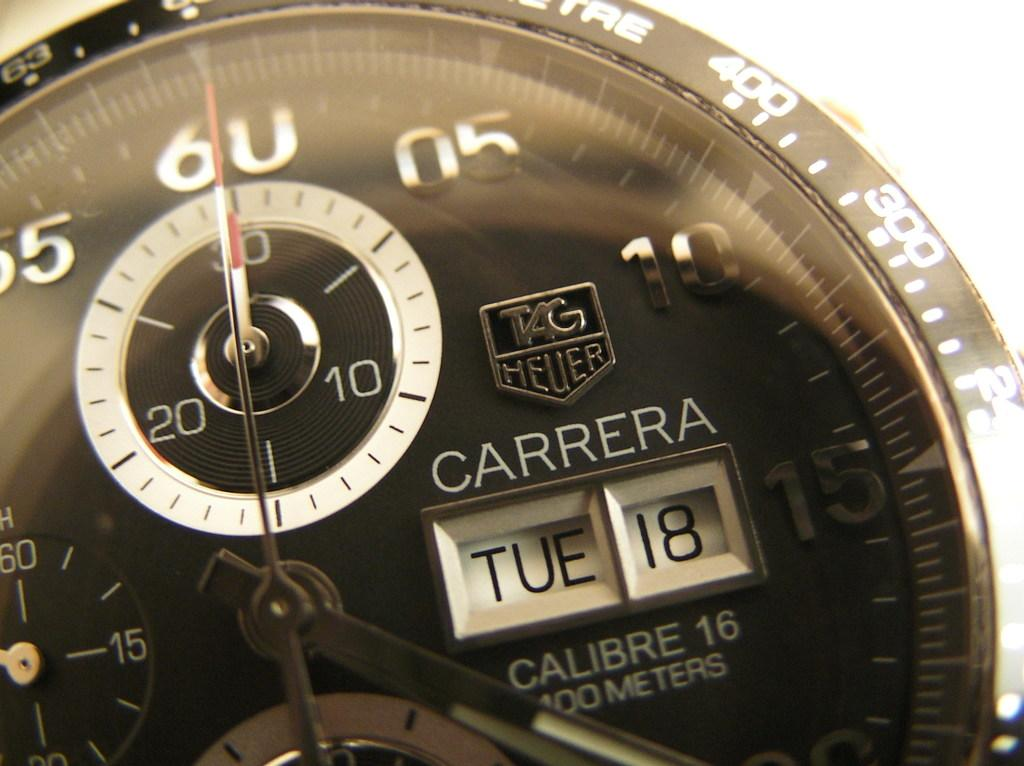<image>
Relay a brief, clear account of the picture shown. A Carrera watch displays the day and date of TUE 18. 